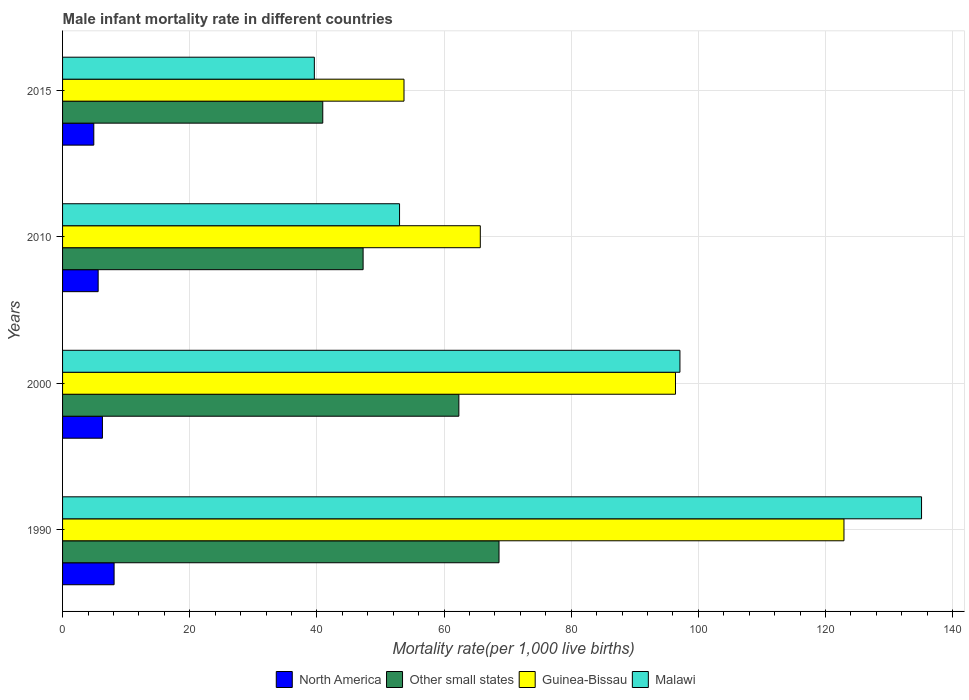How many different coloured bars are there?
Keep it short and to the point. 4. How many bars are there on the 2nd tick from the top?
Give a very brief answer. 4. How many bars are there on the 2nd tick from the bottom?
Your response must be concise. 4. What is the male infant mortality rate in Guinea-Bissau in 2000?
Make the answer very short. 96.4. Across all years, what is the maximum male infant mortality rate in North America?
Offer a very short reply. 8.11. Across all years, what is the minimum male infant mortality rate in Malawi?
Your response must be concise. 39.6. In which year was the male infant mortality rate in Guinea-Bissau maximum?
Ensure brevity in your answer.  1990. In which year was the male infant mortality rate in Guinea-Bissau minimum?
Provide a short and direct response. 2015. What is the total male infant mortality rate in Other small states in the graph?
Make the answer very short. 219.17. What is the difference between the male infant mortality rate in Guinea-Bissau in 2010 and that in 2015?
Give a very brief answer. 12. What is the difference between the male infant mortality rate in Malawi in 1990 and the male infant mortality rate in North America in 2015?
Your response must be concise. 130.19. What is the average male infant mortality rate in North America per year?
Ensure brevity in your answer.  6.22. In the year 2010, what is the difference between the male infant mortality rate in Other small states and male infant mortality rate in Guinea-Bissau?
Offer a terse response. -18.43. In how many years, is the male infant mortality rate in Malawi greater than 52 ?
Offer a very short reply. 3. What is the ratio of the male infant mortality rate in Guinea-Bissau in 1990 to that in 2015?
Give a very brief answer. 2.29. Is the male infant mortality rate in Other small states in 2000 less than that in 2010?
Make the answer very short. No. What is the difference between the highest and the second highest male infant mortality rate in Other small states?
Your response must be concise. 6.32. What is the difference between the highest and the lowest male infant mortality rate in Other small states?
Your answer should be compact. 27.72. What does the 3rd bar from the bottom in 1990 represents?
Keep it short and to the point. Guinea-Bissau. Are all the bars in the graph horizontal?
Your answer should be very brief. Yes. How many years are there in the graph?
Give a very brief answer. 4. What is the title of the graph?
Offer a very short reply. Male infant mortality rate in different countries. What is the label or title of the X-axis?
Provide a succinct answer. Mortality rate(per 1,0 live births). What is the Mortality rate(per 1,000 live births) in North America in 1990?
Your response must be concise. 8.11. What is the Mortality rate(per 1,000 live births) in Other small states in 1990?
Make the answer very short. 68.65. What is the Mortality rate(per 1,000 live births) of Guinea-Bissau in 1990?
Ensure brevity in your answer.  122.9. What is the Mortality rate(per 1,000 live births) of Malawi in 1990?
Provide a short and direct response. 135.1. What is the Mortality rate(per 1,000 live births) of North America in 2000?
Provide a succinct answer. 6.27. What is the Mortality rate(per 1,000 live births) of Other small states in 2000?
Your answer should be compact. 62.33. What is the Mortality rate(per 1,000 live births) of Guinea-Bissau in 2000?
Provide a succinct answer. 96.4. What is the Mortality rate(per 1,000 live births) of Malawi in 2000?
Keep it short and to the point. 97.1. What is the Mortality rate(per 1,000 live births) in North America in 2010?
Provide a short and direct response. 5.6. What is the Mortality rate(per 1,000 live births) of Other small states in 2010?
Ensure brevity in your answer.  47.27. What is the Mortality rate(per 1,000 live births) in Guinea-Bissau in 2010?
Provide a succinct answer. 65.7. What is the Mortality rate(per 1,000 live births) of Malawi in 2010?
Ensure brevity in your answer.  53. What is the Mortality rate(per 1,000 live births) in North America in 2015?
Offer a very short reply. 4.91. What is the Mortality rate(per 1,000 live births) in Other small states in 2015?
Your answer should be compact. 40.92. What is the Mortality rate(per 1,000 live births) of Guinea-Bissau in 2015?
Keep it short and to the point. 53.7. What is the Mortality rate(per 1,000 live births) in Malawi in 2015?
Your answer should be very brief. 39.6. Across all years, what is the maximum Mortality rate(per 1,000 live births) of North America?
Keep it short and to the point. 8.11. Across all years, what is the maximum Mortality rate(per 1,000 live births) of Other small states?
Make the answer very short. 68.65. Across all years, what is the maximum Mortality rate(per 1,000 live births) in Guinea-Bissau?
Provide a short and direct response. 122.9. Across all years, what is the maximum Mortality rate(per 1,000 live births) in Malawi?
Make the answer very short. 135.1. Across all years, what is the minimum Mortality rate(per 1,000 live births) of North America?
Provide a short and direct response. 4.91. Across all years, what is the minimum Mortality rate(per 1,000 live births) of Other small states?
Your response must be concise. 40.92. Across all years, what is the minimum Mortality rate(per 1,000 live births) in Guinea-Bissau?
Provide a succinct answer. 53.7. Across all years, what is the minimum Mortality rate(per 1,000 live births) of Malawi?
Provide a succinct answer. 39.6. What is the total Mortality rate(per 1,000 live births) in North America in the graph?
Offer a very short reply. 24.89. What is the total Mortality rate(per 1,000 live births) in Other small states in the graph?
Provide a short and direct response. 219.17. What is the total Mortality rate(per 1,000 live births) in Guinea-Bissau in the graph?
Provide a succinct answer. 338.7. What is the total Mortality rate(per 1,000 live births) of Malawi in the graph?
Ensure brevity in your answer.  324.8. What is the difference between the Mortality rate(per 1,000 live births) of North America in 1990 and that in 2000?
Offer a very short reply. 1.84. What is the difference between the Mortality rate(per 1,000 live births) in Other small states in 1990 and that in 2000?
Make the answer very short. 6.32. What is the difference between the Mortality rate(per 1,000 live births) in North America in 1990 and that in 2010?
Your answer should be compact. 2.51. What is the difference between the Mortality rate(per 1,000 live births) of Other small states in 1990 and that in 2010?
Offer a very short reply. 21.38. What is the difference between the Mortality rate(per 1,000 live births) in Guinea-Bissau in 1990 and that in 2010?
Your answer should be very brief. 57.2. What is the difference between the Mortality rate(per 1,000 live births) of Malawi in 1990 and that in 2010?
Your answer should be very brief. 82.1. What is the difference between the Mortality rate(per 1,000 live births) of North America in 1990 and that in 2015?
Make the answer very short. 3.19. What is the difference between the Mortality rate(per 1,000 live births) in Other small states in 1990 and that in 2015?
Your answer should be compact. 27.72. What is the difference between the Mortality rate(per 1,000 live births) of Guinea-Bissau in 1990 and that in 2015?
Give a very brief answer. 69.2. What is the difference between the Mortality rate(per 1,000 live births) in Malawi in 1990 and that in 2015?
Provide a short and direct response. 95.5. What is the difference between the Mortality rate(per 1,000 live births) in North America in 2000 and that in 2010?
Offer a terse response. 0.67. What is the difference between the Mortality rate(per 1,000 live births) of Other small states in 2000 and that in 2010?
Make the answer very short. 15.06. What is the difference between the Mortality rate(per 1,000 live births) in Guinea-Bissau in 2000 and that in 2010?
Ensure brevity in your answer.  30.7. What is the difference between the Mortality rate(per 1,000 live births) in Malawi in 2000 and that in 2010?
Provide a short and direct response. 44.1. What is the difference between the Mortality rate(per 1,000 live births) of North America in 2000 and that in 2015?
Ensure brevity in your answer.  1.36. What is the difference between the Mortality rate(per 1,000 live births) of Other small states in 2000 and that in 2015?
Offer a terse response. 21.4. What is the difference between the Mortality rate(per 1,000 live births) in Guinea-Bissau in 2000 and that in 2015?
Provide a succinct answer. 42.7. What is the difference between the Mortality rate(per 1,000 live births) of Malawi in 2000 and that in 2015?
Provide a succinct answer. 57.5. What is the difference between the Mortality rate(per 1,000 live births) in North America in 2010 and that in 2015?
Your answer should be very brief. 0.69. What is the difference between the Mortality rate(per 1,000 live births) in Other small states in 2010 and that in 2015?
Give a very brief answer. 6.34. What is the difference between the Mortality rate(per 1,000 live births) of Malawi in 2010 and that in 2015?
Keep it short and to the point. 13.4. What is the difference between the Mortality rate(per 1,000 live births) of North America in 1990 and the Mortality rate(per 1,000 live births) of Other small states in 2000?
Ensure brevity in your answer.  -54.22. What is the difference between the Mortality rate(per 1,000 live births) in North America in 1990 and the Mortality rate(per 1,000 live births) in Guinea-Bissau in 2000?
Your answer should be very brief. -88.29. What is the difference between the Mortality rate(per 1,000 live births) in North America in 1990 and the Mortality rate(per 1,000 live births) in Malawi in 2000?
Give a very brief answer. -88.99. What is the difference between the Mortality rate(per 1,000 live births) of Other small states in 1990 and the Mortality rate(per 1,000 live births) of Guinea-Bissau in 2000?
Provide a succinct answer. -27.75. What is the difference between the Mortality rate(per 1,000 live births) in Other small states in 1990 and the Mortality rate(per 1,000 live births) in Malawi in 2000?
Your response must be concise. -28.45. What is the difference between the Mortality rate(per 1,000 live births) in Guinea-Bissau in 1990 and the Mortality rate(per 1,000 live births) in Malawi in 2000?
Your response must be concise. 25.8. What is the difference between the Mortality rate(per 1,000 live births) of North America in 1990 and the Mortality rate(per 1,000 live births) of Other small states in 2010?
Provide a short and direct response. -39.16. What is the difference between the Mortality rate(per 1,000 live births) of North America in 1990 and the Mortality rate(per 1,000 live births) of Guinea-Bissau in 2010?
Provide a succinct answer. -57.59. What is the difference between the Mortality rate(per 1,000 live births) in North America in 1990 and the Mortality rate(per 1,000 live births) in Malawi in 2010?
Keep it short and to the point. -44.89. What is the difference between the Mortality rate(per 1,000 live births) of Other small states in 1990 and the Mortality rate(per 1,000 live births) of Guinea-Bissau in 2010?
Provide a succinct answer. 2.94. What is the difference between the Mortality rate(per 1,000 live births) in Other small states in 1990 and the Mortality rate(per 1,000 live births) in Malawi in 2010?
Your answer should be compact. 15.64. What is the difference between the Mortality rate(per 1,000 live births) in Guinea-Bissau in 1990 and the Mortality rate(per 1,000 live births) in Malawi in 2010?
Provide a succinct answer. 69.9. What is the difference between the Mortality rate(per 1,000 live births) in North America in 1990 and the Mortality rate(per 1,000 live births) in Other small states in 2015?
Provide a succinct answer. -32.82. What is the difference between the Mortality rate(per 1,000 live births) in North America in 1990 and the Mortality rate(per 1,000 live births) in Guinea-Bissau in 2015?
Offer a very short reply. -45.59. What is the difference between the Mortality rate(per 1,000 live births) of North America in 1990 and the Mortality rate(per 1,000 live births) of Malawi in 2015?
Provide a succinct answer. -31.49. What is the difference between the Mortality rate(per 1,000 live births) of Other small states in 1990 and the Mortality rate(per 1,000 live births) of Guinea-Bissau in 2015?
Provide a short and direct response. 14.95. What is the difference between the Mortality rate(per 1,000 live births) of Other small states in 1990 and the Mortality rate(per 1,000 live births) of Malawi in 2015?
Your answer should be very brief. 29.05. What is the difference between the Mortality rate(per 1,000 live births) in Guinea-Bissau in 1990 and the Mortality rate(per 1,000 live births) in Malawi in 2015?
Offer a very short reply. 83.3. What is the difference between the Mortality rate(per 1,000 live births) in North America in 2000 and the Mortality rate(per 1,000 live births) in Other small states in 2010?
Offer a very short reply. -41. What is the difference between the Mortality rate(per 1,000 live births) in North America in 2000 and the Mortality rate(per 1,000 live births) in Guinea-Bissau in 2010?
Provide a short and direct response. -59.43. What is the difference between the Mortality rate(per 1,000 live births) in North America in 2000 and the Mortality rate(per 1,000 live births) in Malawi in 2010?
Make the answer very short. -46.73. What is the difference between the Mortality rate(per 1,000 live births) of Other small states in 2000 and the Mortality rate(per 1,000 live births) of Guinea-Bissau in 2010?
Provide a succinct answer. -3.37. What is the difference between the Mortality rate(per 1,000 live births) of Other small states in 2000 and the Mortality rate(per 1,000 live births) of Malawi in 2010?
Offer a terse response. 9.33. What is the difference between the Mortality rate(per 1,000 live births) in Guinea-Bissau in 2000 and the Mortality rate(per 1,000 live births) in Malawi in 2010?
Provide a short and direct response. 43.4. What is the difference between the Mortality rate(per 1,000 live births) of North America in 2000 and the Mortality rate(per 1,000 live births) of Other small states in 2015?
Make the answer very short. -34.66. What is the difference between the Mortality rate(per 1,000 live births) in North America in 2000 and the Mortality rate(per 1,000 live births) in Guinea-Bissau in 2015?
Provide a short and direct response. -47.43. What is the difference between the Mortality rate(per 1,000 live births) in North America in 2000 and the Mortality rate(per 1,000 live births) in Malawi in 2015?
Keep it short and to the point. -33.33. What is the difference between the Mortality rate(per 1,000 live births) in Other small states in 2000 and the Mortality rate(per 1,000 live births) in Guinea-Bissau in 2015?
Provide a short and direct response. 8.63. What is the difference between the Mortality rate(per 1,000 live births) in Other small states in 2000 and the Mortality rate(per 1,000 live births) in Malawi in 2015?
Your answer should be very brief. 22.73. What is the difference between the Mortality rate(per 1,000 live births) of Guinea-Bissau in 2000 and the Mortality rate(per 1,000 live births) of Malawi in 2015?
Your answer should be very brief. 56.8. What is the difference between the Mortality rate(per 1,000 live births) in North America in 2010 and the Mortality rate(per 1,000 live births) in Other small states in 2015?
Your answer should be compact. -35.33. What is the difference between the Mortality rate(per 1,000 live births) in North America in 2010 and the Mortality rate(per 1,000 live births) in Guinea-Bissau in 2015?
Provide a short and direct response. -48.1. What is the difference between the Mortality rate(per 1,000 live births) of North America in 2010 and the Mortality rate(per 1,000 live births) of Malawi in 2015?
Give a very brief answer. -34. What is the difference between the Mortality rate(per 1,000 live births) of Other small states in 2010 and the Mortality rate(per 1,000 live births) of Guinea-Bissau in 2015?
Provide a short and direct response. -6.43. What is the difference between the Mortality rate(per 1,000 live births) of Other small states in 2010 and the Mortality rate(per 1,000 live births) of Malawi in 2015?
Keep it short and to the point. 7.67. What is the difference between the Mortality rate(per 1,000 live births) in Guinea-Bissau in 2010 and the Mortality rate(per 1,000 live births) in Malawi in 2015?
Provide a succinct answer. 26.1. What is the average Mortality rate(per 1,000 live births) in North America per year?
Ensure brevity in your answer.  6.22. What is the average Mortality rate(per 1,000 live births) in Other small states per year?
Provide a succinct answer. 54.79. What is the average Mortality rate(per 1,000 live births) of Guinea-Bissau per year?
Keep it short and to the point. 84.67. What is the average Mortality rate(per 1,000 live births) of Malawi per year?
Offer a terse response. 81.2. In the year 1990, what is the difference between the Mortality rate(per 1,000 live births) of North America and Mortality rate(per 1,000 live births) of Other small states?
Provide a succinct answer. -60.54. In the year 1990, what is the difference between the Mortality rate(per 1,000 live births) of North America and Mortality rate(per 1,000 live births) of Guinea-Bissau?
Your answer should be very brief. -114.79. In the year 1990, what is the difference between the Mortality rate(per 1,000 live births) of North America and Mortality rate(per 1,000 live births) of Malawi?
Your answer should be very brief. -126.99. In the year 1990, what is the difference between the Mortality rate(per 1,000 live births) of Other small states and Mortality rate(per 1,000 live births) of Guinea-Bissau?
Your answer should be compact. -54.26. In the year 1990, what is the difference between the Mortality rate(per 1,000 live births) in Other small states and Mortality rate(per 1,000 live births) in Malawi?
Offer a very short reply. -66.45. In the year 1990, what is the difference between the Mortality rate(per 1,000 live births) of Guinea-Bissau and Mortality rate(per 1,000 live births) of Malawi?
Your answer should be very brief. -12.2. In the year 2000, what is the difference between the Mortality rate(per 1,000 live births) in North America and Mortality rate(per 1,000 live births) in Other small states?
Your answer should be very brief. -56.06. In the year 2000, what is the difference between the Mortality rate(per 1,000 live births) in North America and Mortality rate(per 1,000 live births) in Guinea-Bissau?
Make the answer very short. -90.13. In the year 2000, what is the difference between the Mortality rate(per 1,000 live births) of North America and Mortality rate(per 1,000 live births) of Malawi?
Your answer should be compact. -90.83. In the year 2000, what is the difference between the Mortality rate(per 1,000 live births) in Other small states and Mortality rate(per 1,000 live births) in Guinea-Bissau?
Ensure brevity in your answer.  -34.07. In the year 2000, what is the difference between the Mortality rate(per 1,000 live births) in Other small states and Mortality rate(per 1,000 live births) in Malawi?
Give a very brief answer. -34.77. In the year 2010, what is the difference between the Mortality rate(per 1,000 live births) in North America and Mortality rate(per 1,000 live births) in Other small states?
Give a very brief answer. -41.67. In the year 2010, what is the difference between the Mortality rate(per 1,000 live births) of North America and Mortality rate(per 1,000 live births) of Guinea-Bissau?
Ensure brevity in your answer.  -60.1. In the year 2010, what is the difference between the Mortality rate(per 1,000 live births) of North America and Mortality rate(per 1,000 live births) of Malawi?
Keep it short and to the point. -47.4. In the year 2010, what is the difference between the Mortality rate(per 1,000 live births) of Other small states and Mortality rate(per 1,000 live births) of Guinea-Bissau?
Make the answer very short. -18.43. In the year 2010, what is the difference between the Mortality rate(per 1,000 live births) of Other small states and Mortality rate(per 1,000 live births) of Malawi?
Provide a succinct answer. -5.73. In the year 2010, what is the difference between the Mortality rate(per 1,000 live births) of Guinea-Bissau and Mortality rate(per 1,000 live births) of Malawi?
Make the answer very short. 12.7. In the year 2015, what is the difference between the Mortality rate(per 1,000 live births) in North America and Mortality rate(per 1,000 live births) in Other small states?
Keep it short and to the point. -36.01. In the year 2015, what is the difference between the Mortality rate(per 1,000 live births) in North America and Mortality rate(per 1,000 live births) in Guinea-Bissau?
Make the answer very short. -48.79. In the year 2015, what is the difference between the Mortality rate(per 1,000 live births) in North America and Mortality rate(per 1,000 live births) in Malawi?
Your answer should be very brief. -34.69. In the year 2015, what is the difference between the Mortality rate(per 1,000 live births) in Other small states and Mortality rate(per 1,000 live births) in Guinea-Bissau?
Ensure brevity in your answer.  -12.78. In the year 2015, what is the difference between the Mortality rate(per 1,000 live births) in Other small states and Mortality rate(per 1,000 live births) in Malawi?
Provide a short and direct response. 1.32. What is the ratio of the Mortality rate(per 1,000 live births) of North America in 1990 to that in 2000?
Provide a succinct answer. 1.29. What is the ratio of the Mortality rate(per 1,000 live births) in Other small states in 1990 to that in 2000?
Provide a short and direct response. 1.1. What is the ratio of the Mortality rate(per 1,000 live births) of Guinea-Bissau in 1990 to that in 2000?
Your response must be concise. 1.27. What is the ratio of the Mortality rate(per 1,000 live births) in Malawi in 1990 to that in 2000?
Your answer should be compact. 1.39. What is the ratio of the Mortality rate(per 1,000 live births) in North America in 1990 to that in 2010?
Give a very brief answer. 1.45. What is the ratio of the Mortality rate(per 1,000 live births) in Other small states in 1990 to that in 2010?
Your answer should be compact. 1.45. What is the ratio of the Mortality rate(per 1,000 live births) in Guinea-Bissau in 1990 to that in 2010?
Your answer should be very brief. 1.87. What is the ratio of the Mortality rate(per 1,000 live births) of Malawi in 1990 to that in 2010?
Make the answer very short. 2.55. What is the ratio of the Mortality rate(per 1,000 live births) in North America in 1990 to that in 2015?
Make the answer very short. 1.65. What is the ratio of the Mortality rate(per 1,000 live births) of Other small states in 1990 to that in 2015?
Provide a short and direct response. 1.68. What is the ratio of the Mortality rate(per 1,000 live births) in Guinea-Bissau in 1990 to that in 2015?
Your answer should be compact. 2.29. What is the ratio of the Mortality rate(per 1,000 live births) in Malawi in 1990 to that in 2015?
Provide a succinct answer. 3.41. What is the ratio of the Mortality rate(per 1,000 live births) in North America in 2000 to that in 2010?
Provide a short and direct response. 1.12. What is the ratio of the Mortality rate(per 1,000 live births) in Other small states in 2000 to that in 2010?
Your response must be concise. 1.32. What is the ratio of the Mortality rate(per 1,000 live births) in Guinea-Bissau in 2000 to that in 2010?
Your response must be concise. 1.47. What is the ratio of the Mortality rate(per 1,000 live births) of Malawi in 2000 to that in 2010?
Provide a succinct answer. 1.83. What is the ratio of the Mortality rate(per 1,000 live births) in North America in 2000 to that in 2015?
Your answer should be very brief. 1.28. What is the ratio of the Mortality rate(per 1,000 live births) of Other small states in 2000 to that in 2015?
Offer a terse response. 1.52. What is the ratio of the Mortality rate(per 1,000 live births) in Guinea-Bissau in 2000 to that in 2015?
Offer a very short reply. 1.8. What is the ratio of the Mortality rate(per 1,000 live births) of Malawi in 2000 to that in 2015?
Offer a terse response. 2.45. What is the ratio of the Mortality rate(per 1,000 live births) in North America in 2010 to that in 2015?
Your answer should be very brief. 1.14. What is the ratio of the Mortality rate(per 1,000 live births) in Other small states in 2010 to that in 2015?
Keep it short and to the point. 1.16. What is the ratio of the Mortality rate(per 1,000 live births) in Guinea-Bissau in 2010 to that in 2015?
Provide a succinct answer. 1.22. What is the ratio of the Mortality rate(per 1,000 live births) in Malawi in 2010 to that in 2015?
Your answer should be very brief. 1.34. What is the difference between the highest and the second highest Mortality rate(per 1,000 live births) of North America?
Your answer should be very brief. 1.84. What is the difference between the highest and the second highest Mortality rate(per 1,000 live births) in Other small states?
Your response must be concise. 6.32. What is the difference between the highest and the lowest Mortality rate(per 1,000 live births) in North America?
Your answer should be very brief. 3.19. What is the difference between the highest and the lowest Mortality rate(per 1,000 live births) in Other small states?
Ensure brevity in your answer.  27.72. What is the difference between the highest and the lowest Mortality rate(per 1,000 live births) of Guinea-Bissau?
Make the answer very short. 69.2. What is the difference between the highest and the lowest Mortality rate(per 1,000 live births) of Malawi?
Provide a succinct answer. 95.5. 